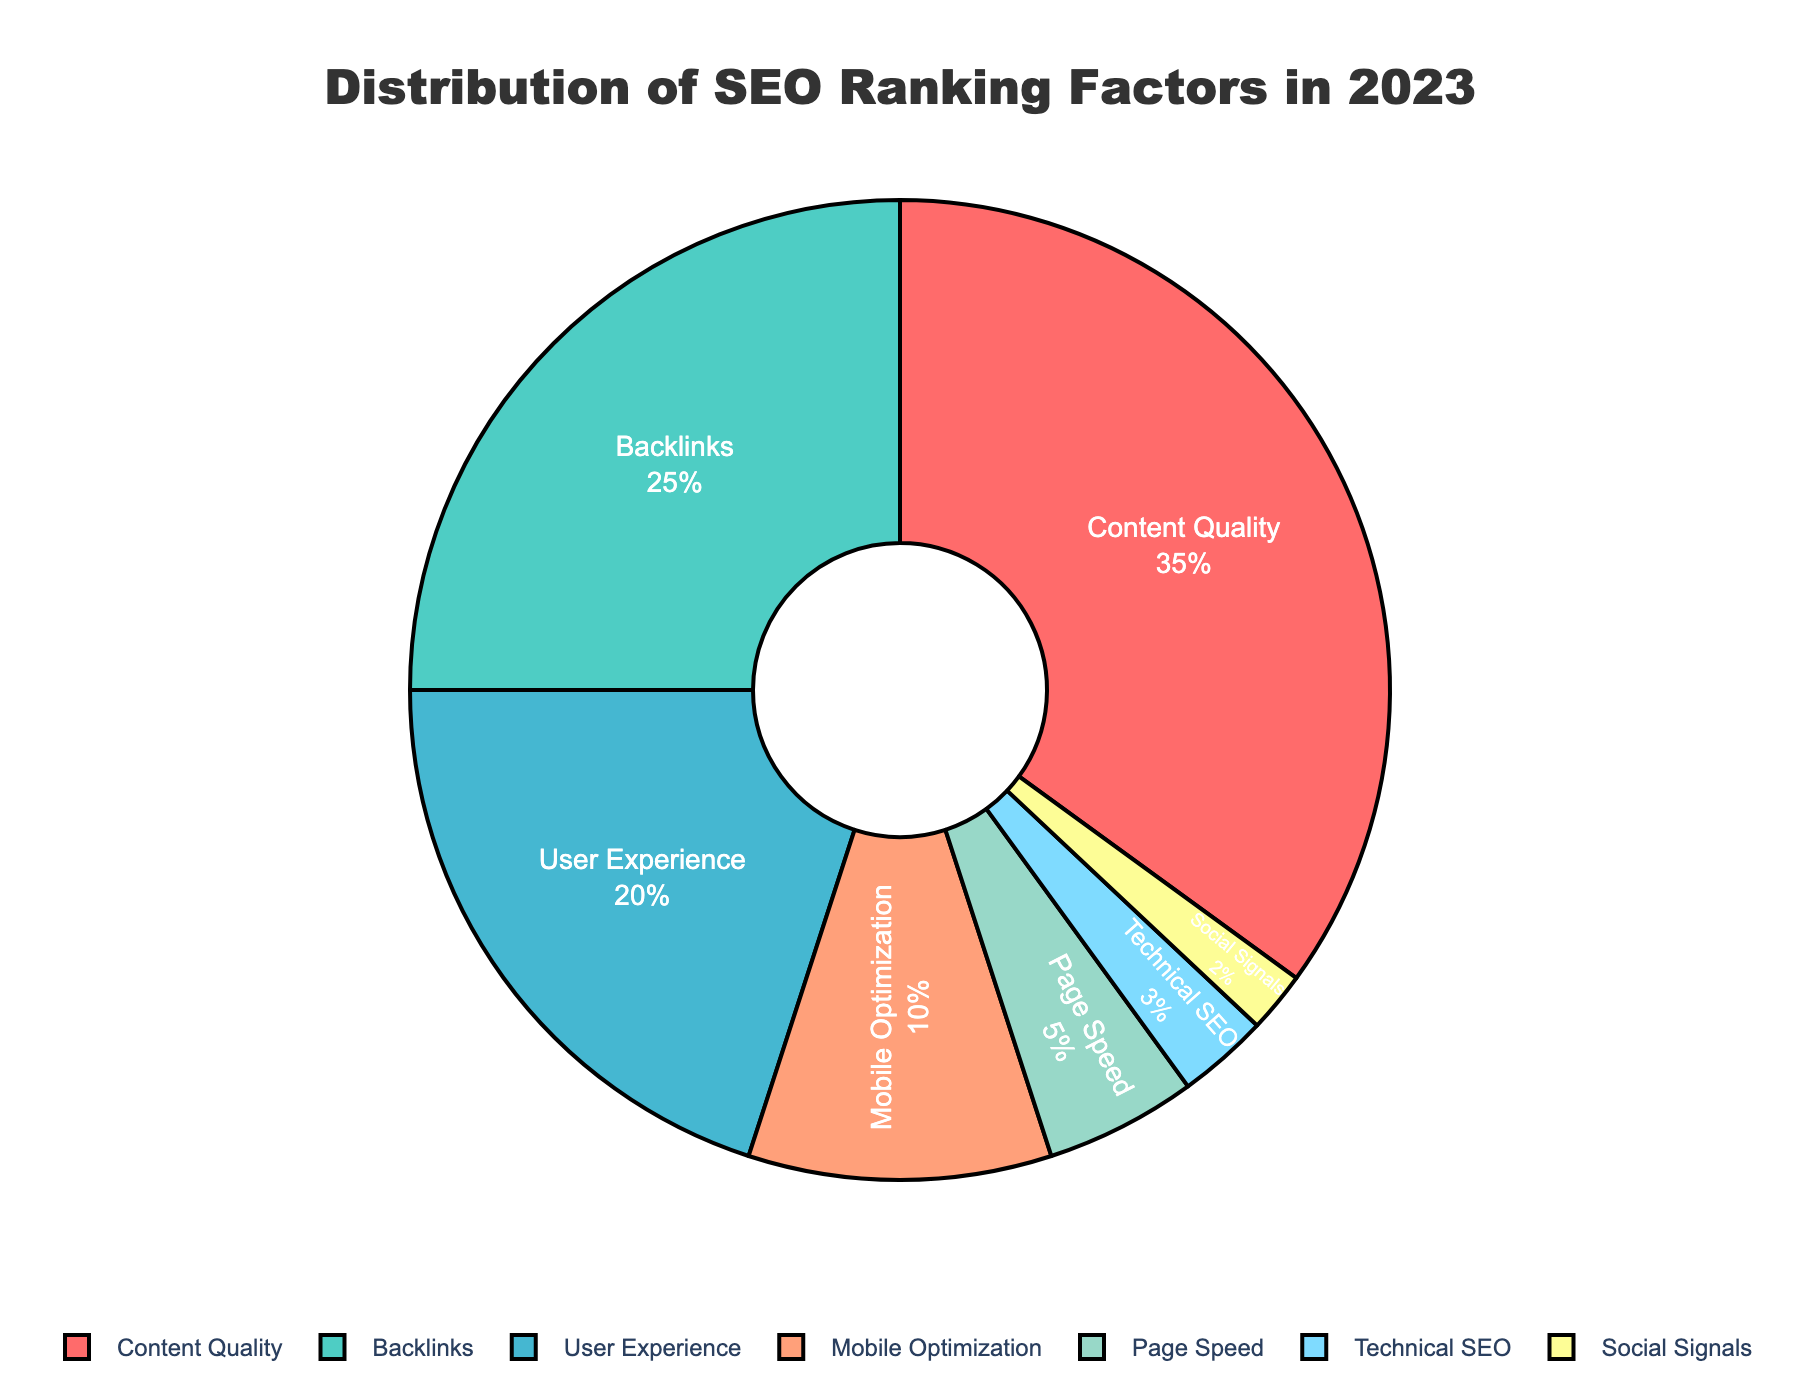What is the percentage contribution of Content Quality and Backlinks together? The percentage contribution of Content Quality is 35% and Backlinks is 25%. Adding these two together gives 35% + 25% = 60%.
Answer: 60% How does the percentage of User Experience compare to Mobile Optimization? The percentage contribution of User Experience is 20%, while Mobile Optimization is 10%. Therefore, User Experience is 20% - 10% = 10% greater than Mobile Optimization.
Answer: 10% more Which category has the least percentage contribution to SEO ranking factors? From the figure, Social Signals have the smallest segment, which corresponds to the lowest percentage.
Answer: Social Signals What percentage of the SEO ranking factors is not attributed to Content Quality? Content Quality contributes 35%. Subtracting this from 100%, we get 100% - 35% = 65%.
Answer: 65% By what percentage does Page Speed exceed Social Signals? Page Speed contributes 5%, while Social Signals contribute 2%. The difference is 5% - 2% = 3%.
Answer: 3% What is the combined percentage of Technical SEO and Social Signals? Technical SEO contributes 3% and Social Signals contribute 2%. Adding these together gives 3% + 2% = 5%.
Answer: 5% How does Technical SEO's contribution relate to that of User Experience in terms of percentage? Technical SEO has a contribution of 3%, while User Experience has 20%. Dividing 20% by 3% gives approximately 6.67 times.
Answer: 6.67 times If you sum the percentages of all factors except Backlinks, what do you get? Excluding Backlinks which has 25%, the other percentages are: Content Quality (35%), User Experience (20%), Mobile Optimization (10%), Page Speed (5%), Technical SEO (3%), Social Signals (2%). Adding these together: 35% + 20% + 10% + 5% + 3% + 2% = 75%.
Answer: 75% Is Mobile Optimization's percentage closer to Page Speed or User Experience? Mobile Optimization is 10%. Page Speed is 5%, and User Experience is 20%. The difference between Mobile Optimization and Page Speed is 10% - 5% = 5%. The difference between Mobile Optimization and User Experience is 20% - 10% = 10%. Therefore, it is closer to Page Speed.
Answer: Closer to Page Speed 